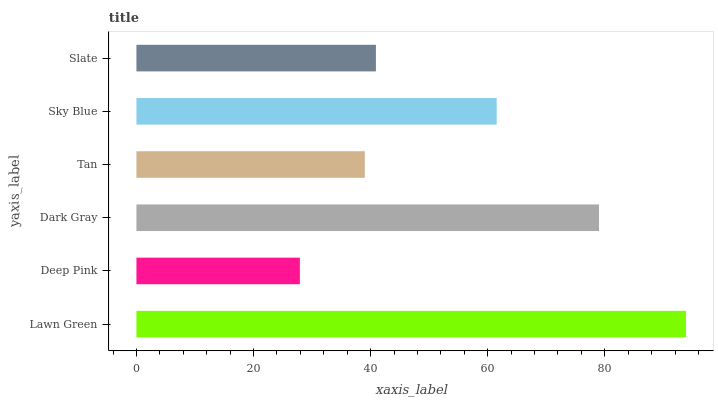Is Deep Pink the minimum?
Answer yes or no. Yes. Is Lawn Green the maximum?
Answer yes or no. Yes. Is Dark Gray the minimum?
Answer yes or no. No. Is Dark Gray the maximum?
Answer yes or no. No. Is Dark Gray greater than Deep Pink?
Answer yes or no. Yes. Is Deep Pink less than Dark Gray?
Answer yes or no. Yes. Is Deep Pink greater than Dark Gray?
Answer yes or no. No. Is Dark Gray less than Deep Pink?
Answer yes or no. No. Is Sky Blue the high median?
Answer yes or no. Yes. Is Slate the low median?
Answer yes or no. Yes. Is Slate the high median?
Answer yes or no. No. Is Lawn Green the low median?
Answer yes or no. No. 